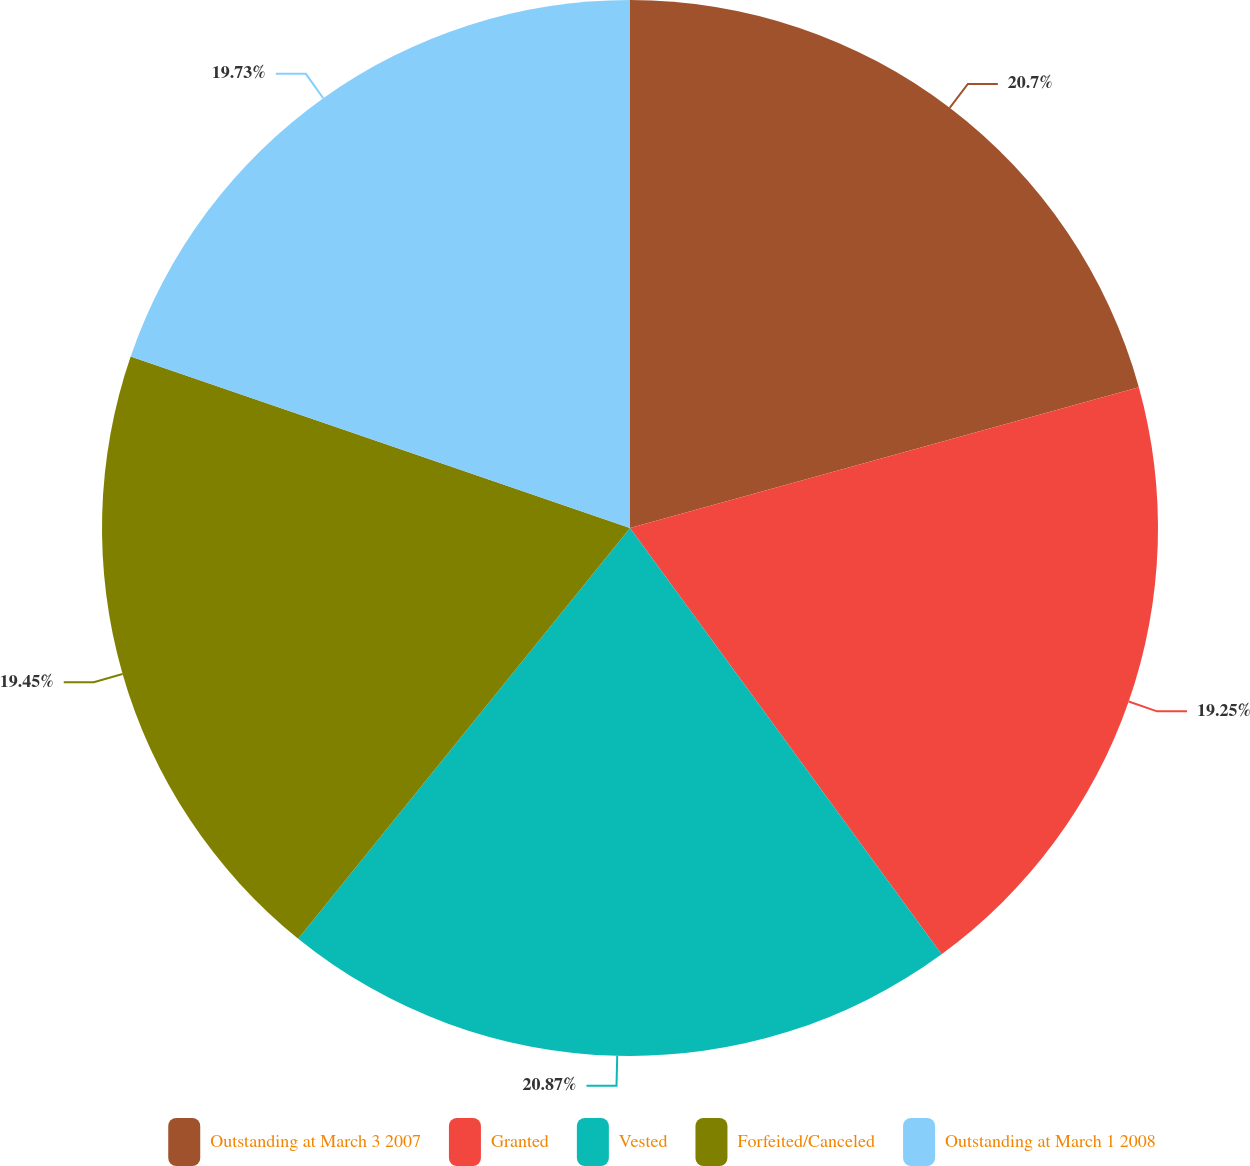<chart> <loc_0><loc_0><loc_500><loc_500><pie_chart><fcel>Outstanding at March 3 2007<fcel>Granted<fcel>Vested<fcel>Forfeited/Canceled<fcel>Outstanding at March 1 2008<nl><fcel>20.7%<fcel>19.25%<fcel>20.86%<fcel>19.45%<fcel>19.73%<nl></chart> 